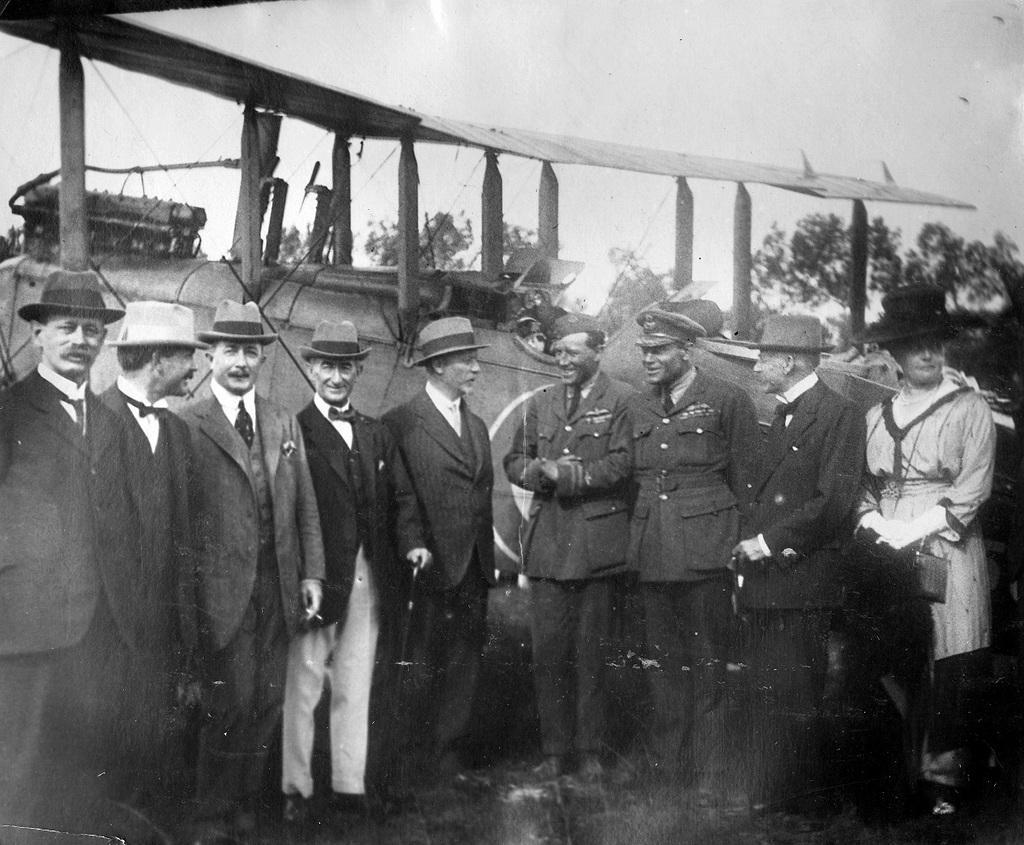Describe this image in one or two sentences. In this image I can see there are few persons wearing caps visible in foreground, in the background I can see tents and vehicles ,at the top I can see the sky and trees visible in the middle. 